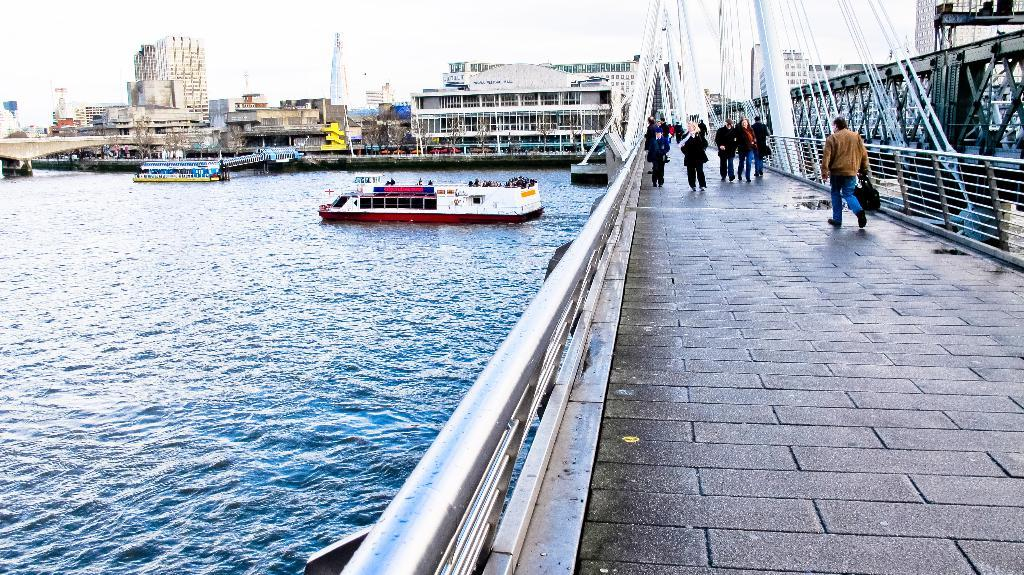What is located in the center of the image? There are boats, buildings, a bridge, and persons in the center of the image. What type of structures can be seen in the image? There are buildings and a bridge in the image. What is the setting of the image? The image features a body of water, a road, and a sky, suggesting it is a waterfront or riverside area. What is visible at the top of the image? The sky is visible at the top of the image. What is present at the bottom of the image? There is water and a road at the bottom of the image. What year is depicted in the image? The year is not depicted in the image, as it is a photograph or illustration of a scene and not a historical document. What type of basin is used to hold the water in the image? There is no specific basin mentioned or depicted in the image; it simply shows a body of water. 